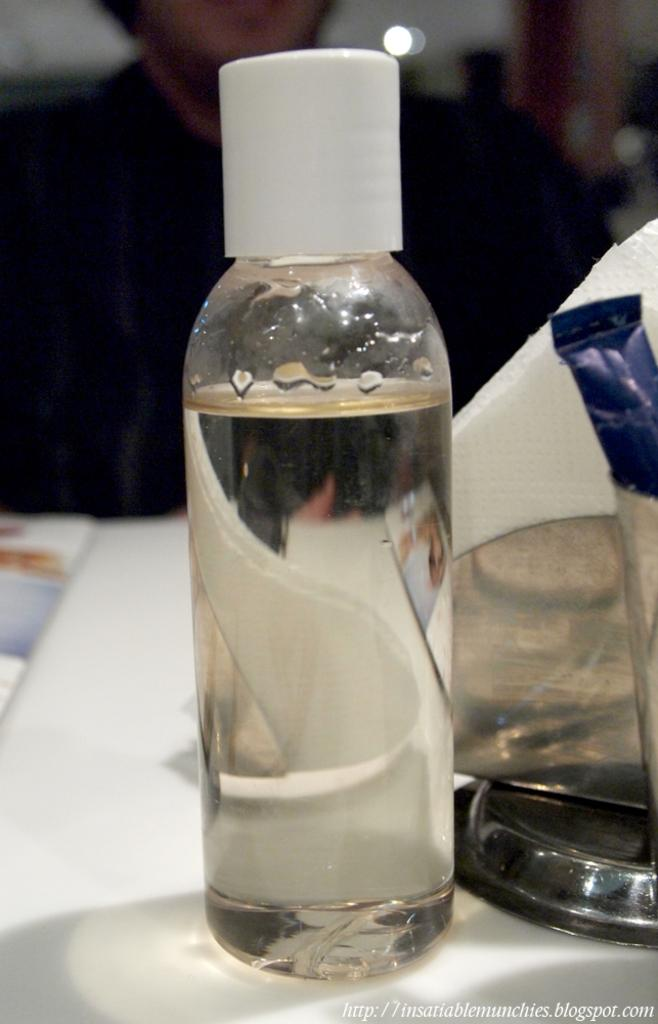What object can be seen in the image that is used for holding liquids? There is a water bottle in the image that is used for holding liquids. Where is the water bottle placed in the image? The water bottle is placed on a table in the image. What item is located beside the water bottle? There are tissue papers beside the water bottle in the image. What is the man in the image wearing? The man in the image is wearing a black shirt. What is the man's position in the image? The man is sitting on a chair in the image. What type of pot is being used to create a zephyr in the image? There is no pot or zephyr present in the image. What type of prose is being written on the tissue papers in the image? There is no writing or prose on the tissue papers in the image. 